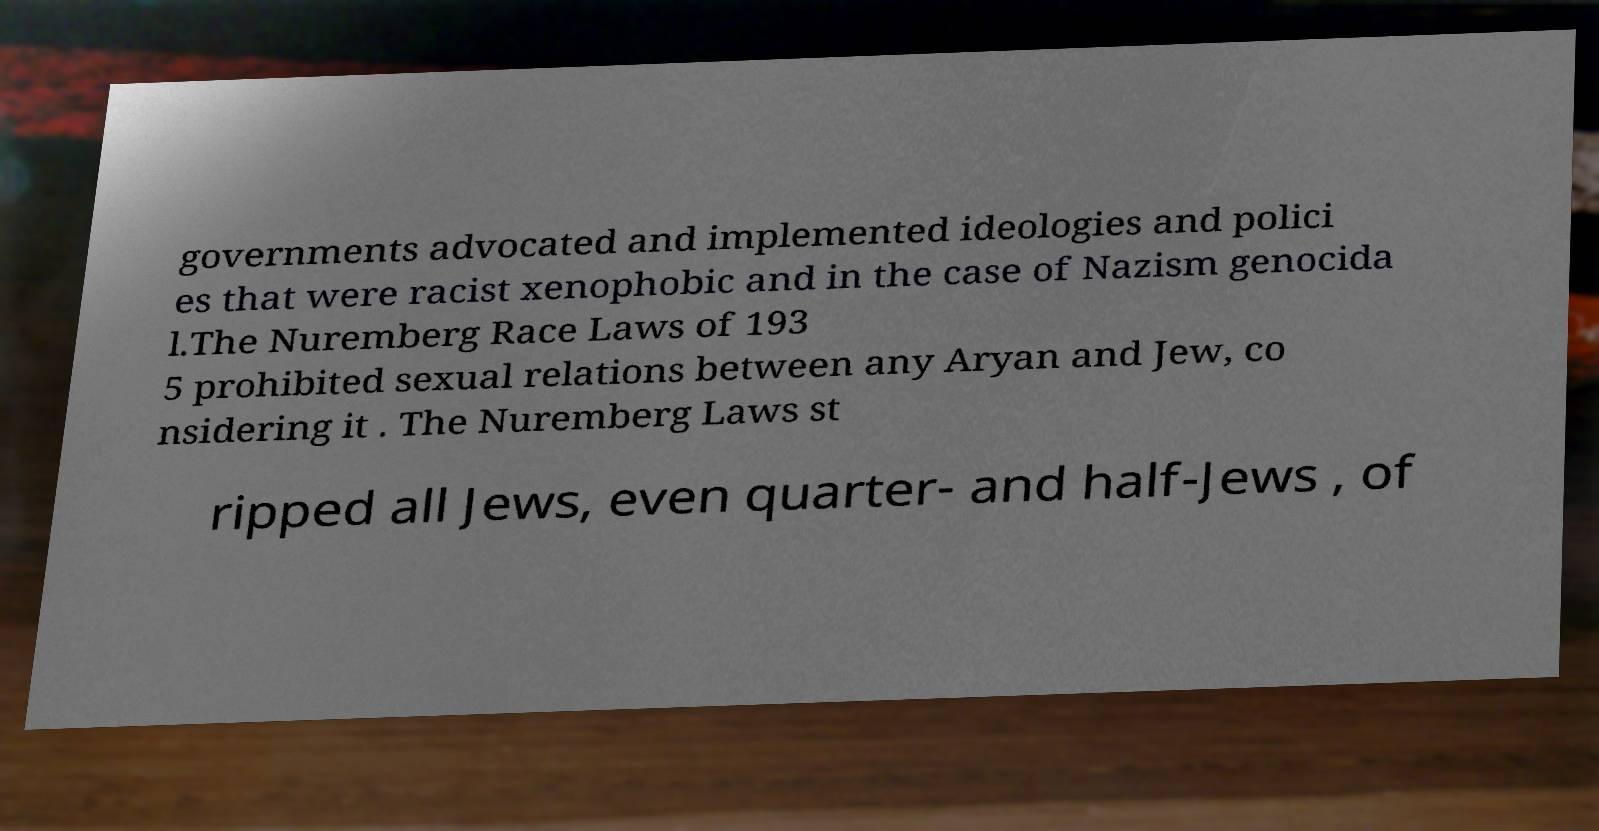Could you assist in decoding the text presented in this image and type it out clearly? governments advocated and implemented ideologies and polici es that were racist xenophobic and in the case of Nazism genocida l.The Nuremberg Race Laws of 193 5 prohibited sexual relations between any Aryan and Jew, co nsidering it . The Nuremberg Laws st ripped all Jews, even quarter- and half-Jews , of 